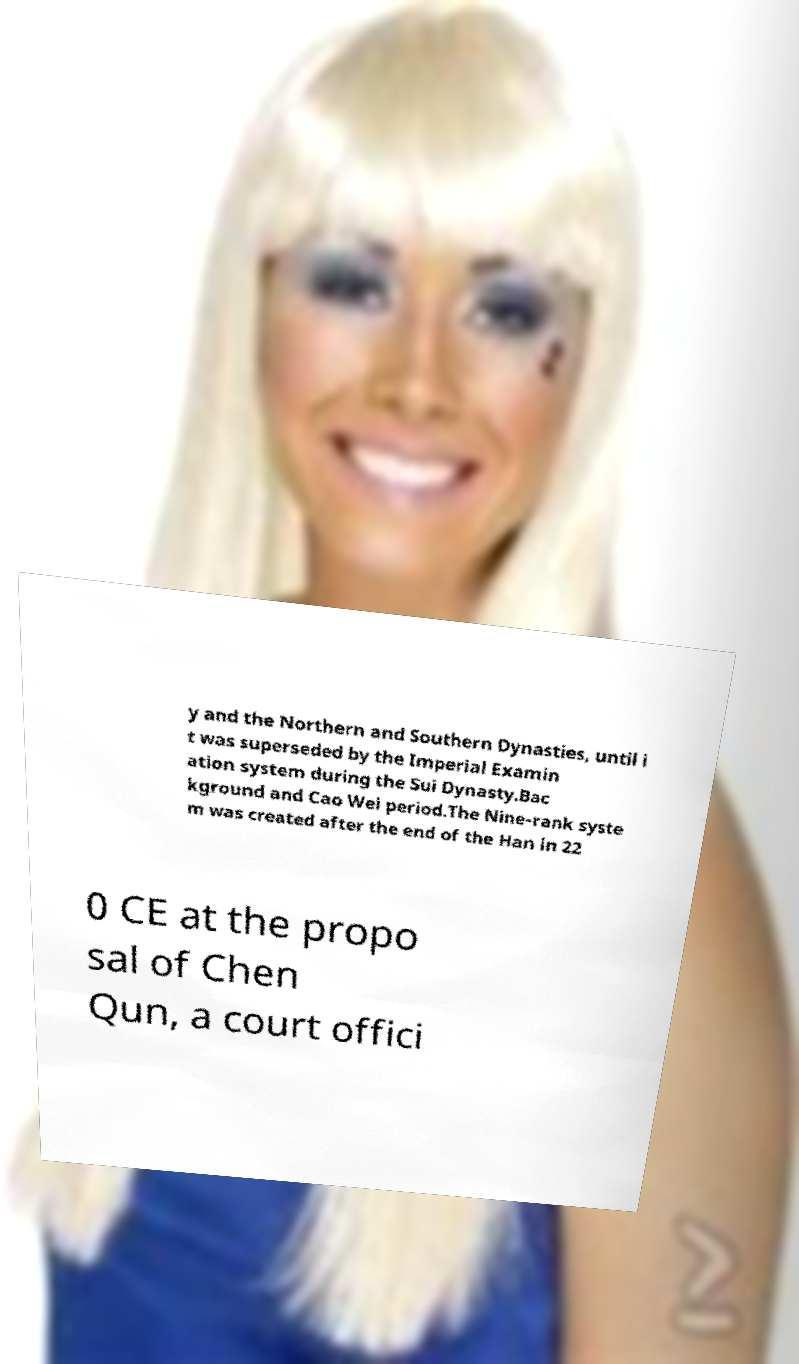Can you read and provide the text displayed in the image?This photo seems to have some interesting text. Can you extract and type it out for me? y and the Northern and Southern Dynasties, until i t was superseded by the Imperial Examin ation system during the Sui Dynasty.Bac kground and Cao Wei period.The Nine-rank syste m was created after the end of the Han in 22 0 CE at the propo sal of Chen Qun, a court offici 